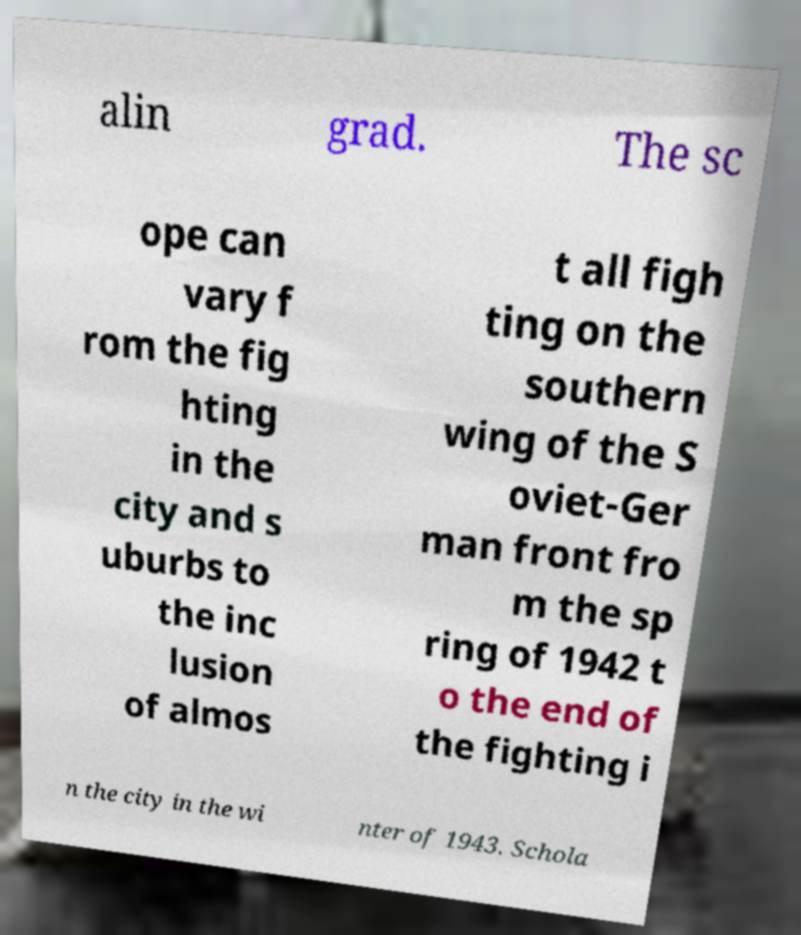Please identify and transcribe the text found in this image. alin grad. The sc ope can vary f rom the fig hting in the city and s uburbs to the inc lusion of almos t all figh ting on the southern wing of the S oviet-Ger man front fro m the sp ring of 1942 t o the end of the fighting i n the city in the wi nter of 1943. Schola 